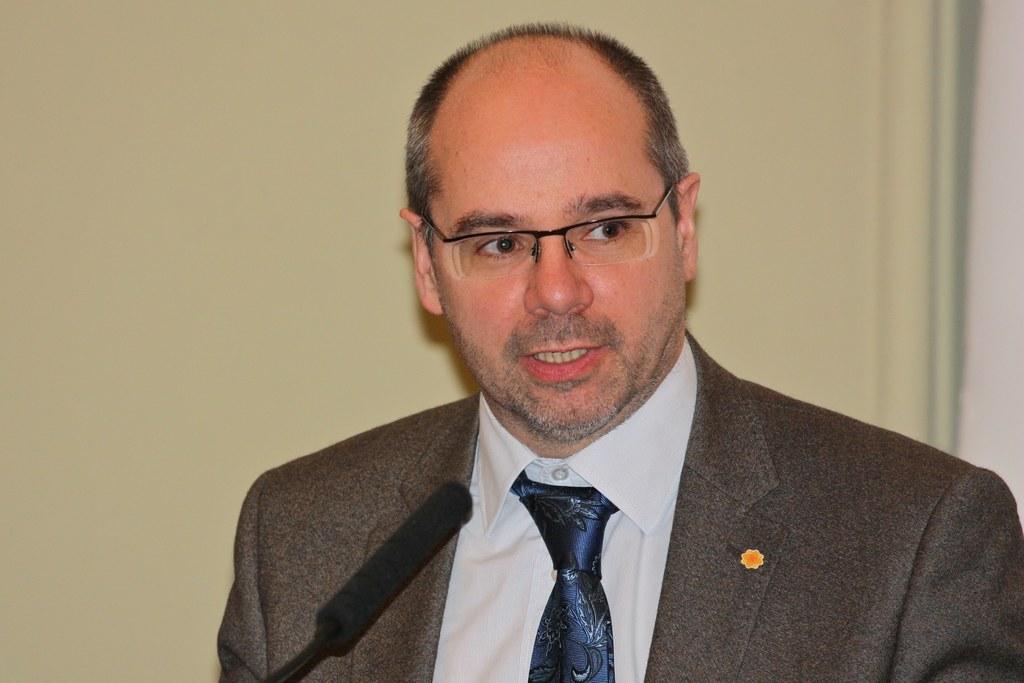Please provide a concise description of this image. Here I can see a man wearing a suit and speaking on the mike by looking at the right side. In the background there is a wall. 